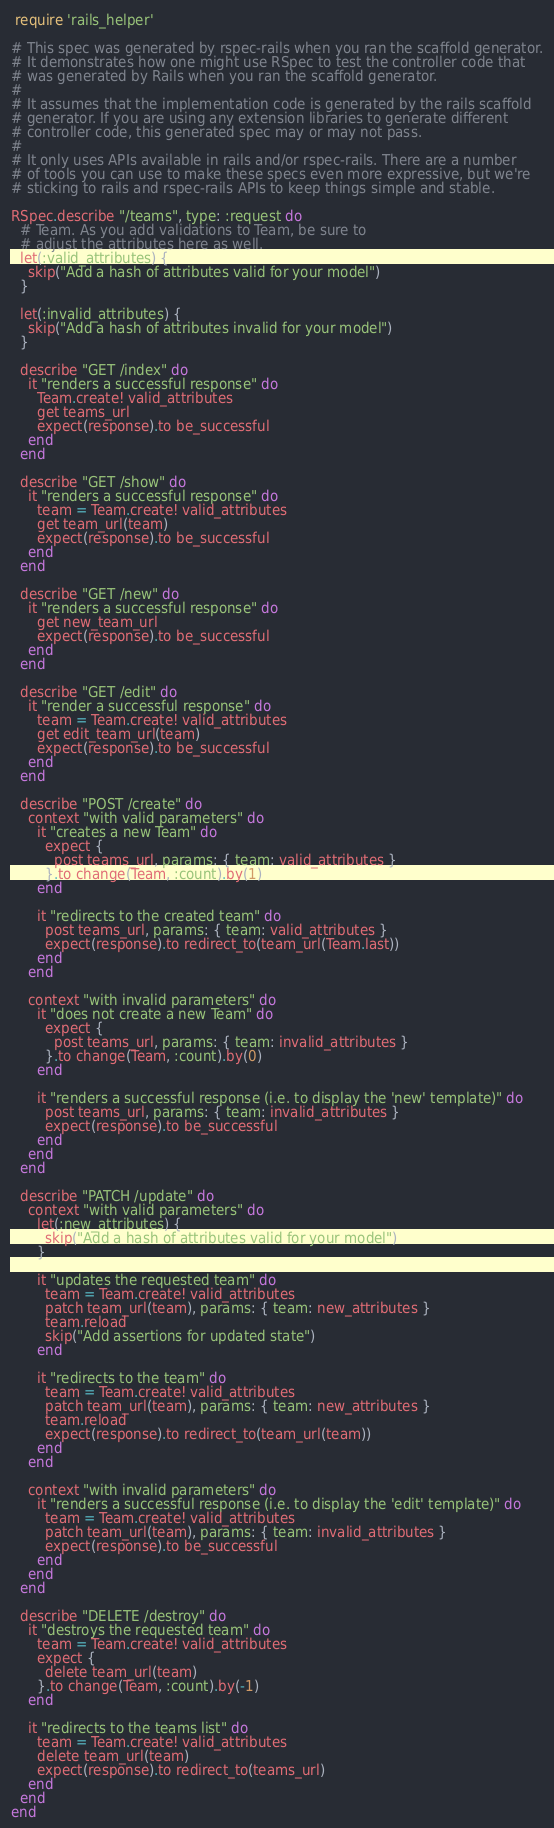Convert code to text. <code><loc_0><loc_0><loc_500><loc_500><_Ruby_> require 'rails_helper'

# This spec was generated by rspec-rails when you ran the scaffold generator.
# It demonstrates how one might use RSpec to test the controller code that
# was generated by Rails when you ran the scaffold generator.
#
# It assumes that the implementation code is generated by the rails scaffold
# generator. If you are using any extension libraries to generate different
# controller code, this generated spec may or may not pass.
#
# It only uses APIs available in rails and/or rspec-rails. There are a number
# of tools you can use to make these specs even more expressive, but we're
# sticking to rails and rspec-rails APIs to keep things simple and stable.

RSpec.describe "/teams", type: :request do
  # Team. As you add validations to Team, be sure to
  # adjust the attributes here as well.
  let(:valid_attributes) {
    skip("Add a hash of attributes valid for your model")
  }

  let(:invalid_attributes) {
    skip("Add a hash of attributes invalid for your model")
  }

  describe "GET /index" do
    it "renders a successful response" do
      Team.create! valid_attributes
      get teams_url
      expect(response).to be_successful
    end
  end

  describe "GET /show" do
    it "renders a successful response" do
      team = Team.create! valid_attributes
      get team_url(team)
      expect(response).to be_successful
    end
  end

  describe "GET /new" do
    it "renders a successful response" do
      get new_team_url
      expect(response).to be_successful
    end
  end

  describe "GET /edit" do
    it "render a successful response" do
      team = Team.create! valid_attributes
      get edit_team_url(team)
      expect(response).to be_successful
    end
  end

  describe "POST /create" do
    context "with valid parameters" do
      it "creates a new Team" do
        expect {
          post teams_url, params: { team: valid_attributes }
        }.to change(Team, :count).by(1)
      end

      it "redirects to the created team" do
        post teams_url, params: { team: valid_attributes }
        expect(response).to redirect_to(team_url(Team.last))
      end
    end

    context "with invalid parameters" do
      it "does not create a new Team" do
        expect {
          post teams_url, params: { team: invalid_attributes }
        }.to change(Team, :count).by(0)
      end

      it "renders a successful response (i.e. to display the 'new' template)" do
        post teams_url, params: { team: invalid_attributes }
        expect(response).to be_successful
      end
    end
  end

  describe "PATCH /update" do
    context "with valid parameters" do
      let(:new_attributes) {
        skip("Add a hash of attributes valid for your model")
      }

      it "updates the requested team" do
        team = Team.create! valid_attributes
        patch team_url(team), params: { team: new_attributes }
        team.reload
        skip("Add assertions for updated state")
      end

      it "redirects to the team" do
        team = Team.create! valid_attributes
        patch team_url(team), params: { team: new_attributes }
        team.reload
        expect(response).to redirect_to(team_url(team))
      end
    end

    context "with invalid parameters" do
      it "renders a successful response (i.e. to display the 'edit' template)" do
        team = Team.create! valid_attributes
        patch team_url(team), params: { team: invalid_attributes }
        expect(response).to be_successful
      end
    end
  end

  describe "DELETE /destroy" do
    it "destroys the requested team" do
      team = Team.create! valid_attributes
      expect {
        delete team_url(team)
      }.to change(Team, :count).by(-1)
    end

    it "redirects to the teams list" do
      team = Team.create! valid_attributes
      delete team_url(team)
      expect(response).to redirect_to(teams_url)
    end
  end
end
</code> 